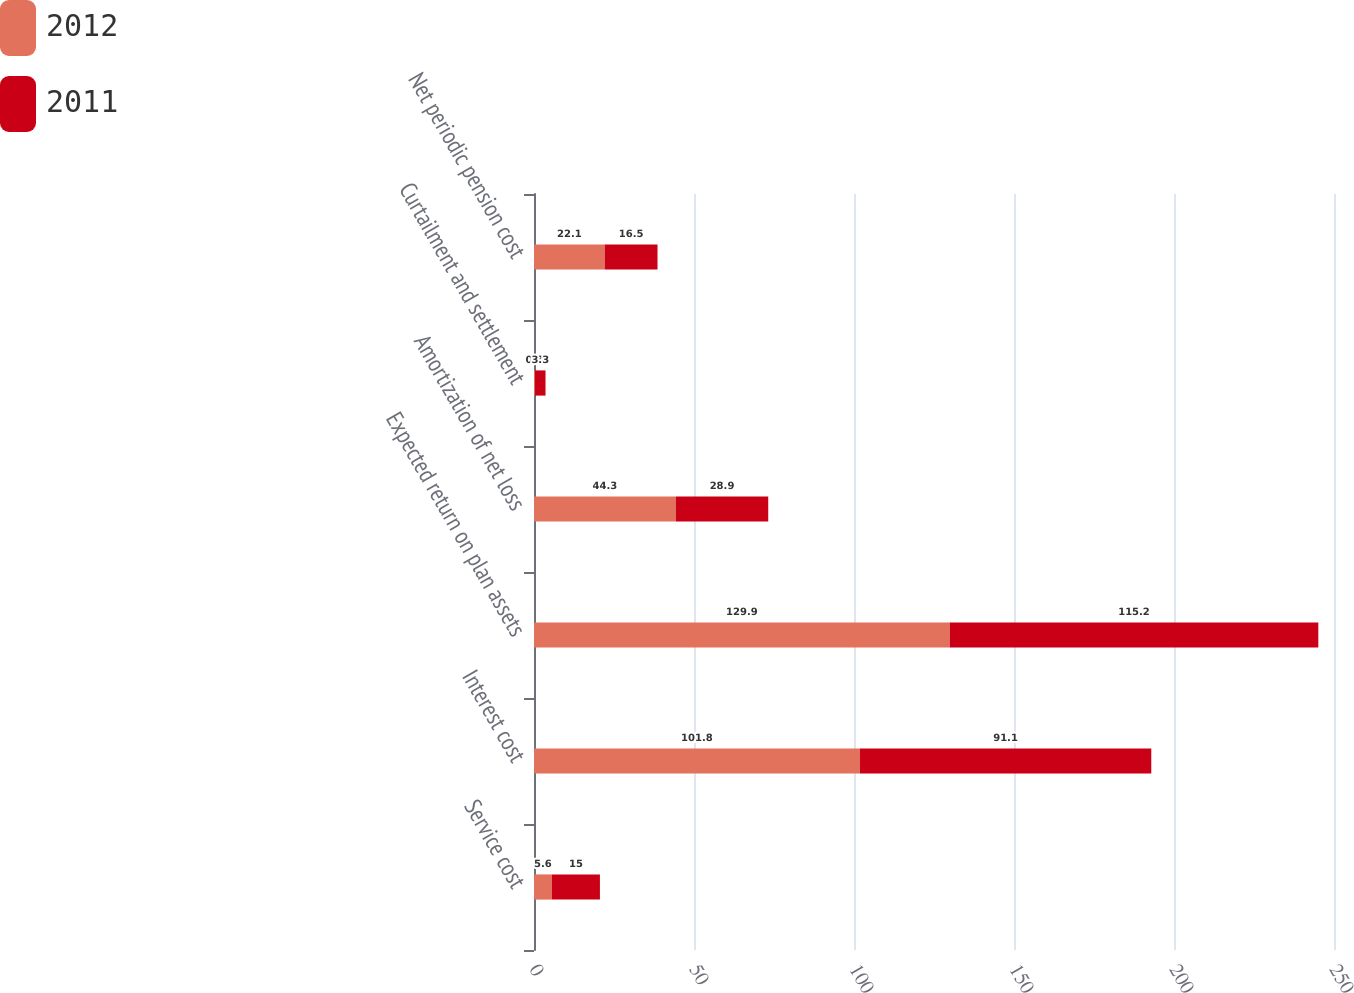<chart> <loc_0><loc_0><loc_500><loc_500><stacked_bar_chart><ecel><fcel>Service cost<fcel>Interest cost<fcel>Expected return on plan assets<fcel>Amortization of net loss<fcel>Curtailment and settlement<fcel>Net periodic pension cost<nl><fcel>2012<fcel>5.6<fcel>101.8<fcel>129.9<fcel>44.3<fcel>0.3<fcel>22.1<nl><fcel>2011<fcel>15<fcel>91.1<fcel>115.2<fcel>28.9<fcel>3.3<fcel>16.5<nl></chart> 